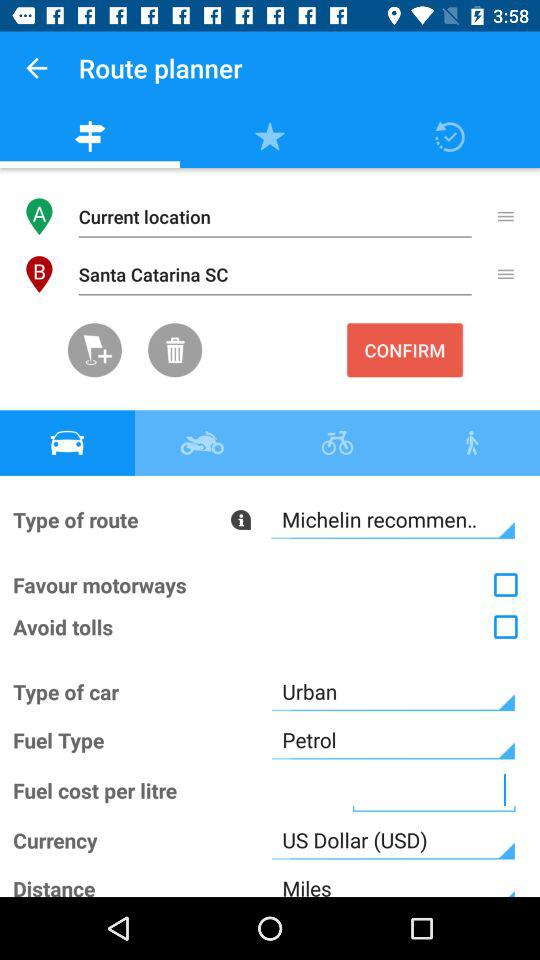What is the status of the "Avoid tolls"? The status of the "Avoid tolls" is "off". 